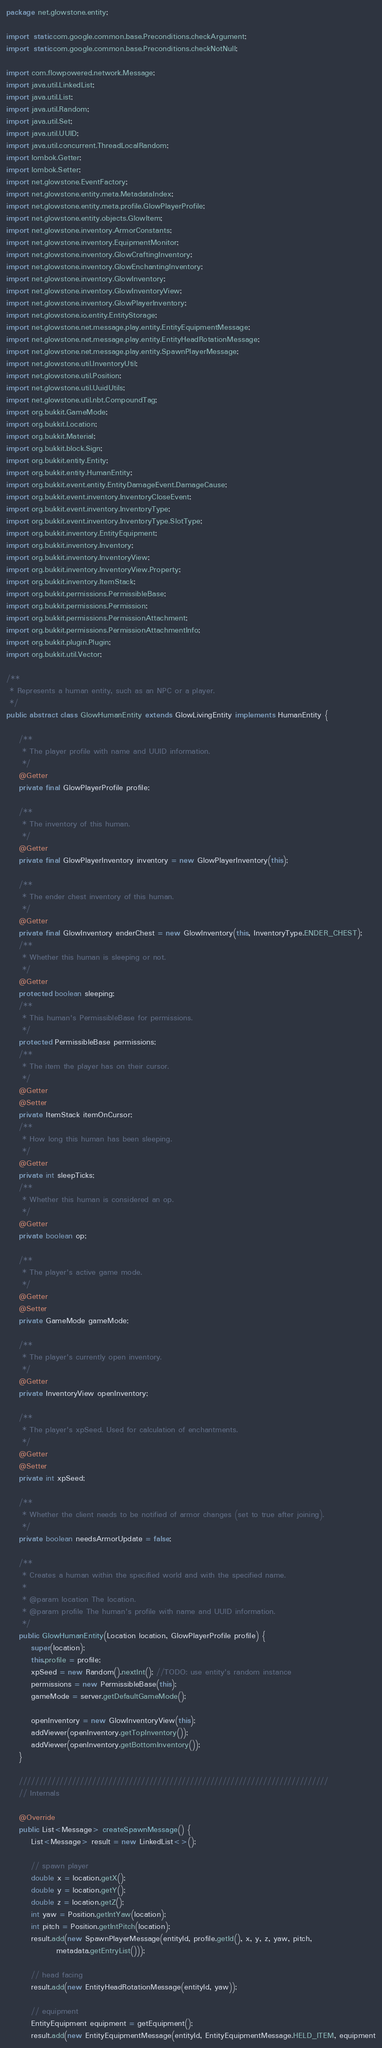Convert code to text. <code><loc_0><loc_0><loc_500><loc_500><_Java_>package net.glowstone.entity;

import static com.google.common.base.Preconditions.checkArgument;
import static com.google.common.base.Preconditions.checkNotNull;

import com.flowpowered.network.Message;
import java.util.LinkedList;
import java.util.List;
import java.util.Random;
import java.util.Set;
import java.util.UUID;
import java.util.concurrent.ThreadLocalRandom;
import lombok.Getter;
import lombok.Setter;
import net.glowstone.EventFactory;
import net.glowstone.entity.meta.MetadataIndex;
import net.glowstone.entity.meta.profile.GlowPlayerProfile;
import net.glowstone.entity.objects.GlowItem;
import net.glowstone.inventory.ArmorConstants;
import net.glowstone.inventory.EquipmentMonitor;
import net.glowstone.inventory.GlowCraftingInventory;
import net.glowstone.inventory.GlowEnchantingInventory;
import net.glowstone.inventory.GlowInventory;
import net.glowstone.inventory.GlowInventoryView;
import net.glowstone.inventory.GlowPlayerInventory;
import net.glowstone.io.entity.EntityStorage;
import net.glowstone.net.message.play.entity.EntityEquipmentMessage;
import net.glowstone.net.message.play.entity.EntityHeadRotationMessage;
import net.glowstone.net.message.play.entity.SpawnPlayerMessage;
import net.glowstone.util.InventoryUtil;
import net.glowstone.util.Position;
import net.glowstone.util.UuidUtils;
import net.glowstone.util.nbt.CompoundTag;
import org.bukkit.GameMode;
import org.bukkit.Location;
import org.bukkit.Material;
import org.bukkit.block.Sign;
import org.bukkit.entity.Entity;
import org.bukkit.entity.HumanEntity;
import org.bukkit.event.entity.EntityDamageEvent.DamageCause;
import org.bukkit.event.inventory.InventoryCloseEvent;
import org.bukkit.event.inventory.InventoryType;
import org.bukkit.event.inventory.InventoryType.SlotType;
import org.bukkit.inventory.EntityEquipment;
import org.bukkit.inventory.Inventory;
import org.bukkit.inventory.InventoryView;
import org.bukkit.inventory.InventoryView.Property;
import org.bukkit.inventory.ItemStack;
import org.bukkit.permissions.PermissibleBase;
import org.bukkit.permissions.Permission;
import org.bukkit.permissions.PermissionAttachment;
import org.bukkit.permissions.PermissionAttachmentInfo;
import org.bukkit.plugin.Plugin;
import org.bukkit.util.Vector;

/**
 * Represents a human entity, such as an NPC or a player.
 */
public abstract class GlowHumanEntity extends GlowLivingEntity implements HumanEntity {

    /**
     * The player profile with name and UUID information.
     */
    @Getter
    private final GlowPlayerProfile profile;

    /**
     * The inventory of this human.
     */
    @Getter
    private final GlowPlayerInventory inventory = new GlowPlayerInventory(this);

    /**
     * The ender chest inventory of this human.
     */
    @Getter
    private final GlowInventory enderChest = new GlowInventory(this, InventoryType.ENDER_CHEST);
    /**
     * Whether this human is sleeping or not.
     */
    @Getter
    protected boolean sleeping;
    /**
     * This human's PermissibleBase for permissions.
     */
    protected PermissibleBase permissions;
    /**
     * The item the player has on their cursor.
     */
    @Getter
    @Setter
    private ItemStack itemOnCursor;
    /**
     * How long this human has been sleeping.
     */
    @Getter
    private int sleepTicks;
    /**
     * Whether this human is considered an op.
     */
    @Getter
    private boolean op;

    /**
     * The player's active game mode.
     */
    @Getter
    @Setter
    private GameMode gameMode;

    /**
     * The player's currently open inventory.
     */
    @Getter
    private InventoryView openInventory;

    /**
     * The player's xpSeed. Used for calculation of enchantments.
     */
    @Getter
    @Setter
    private int xpSeed;

    /**
     * Whether the client needs to be notified of armor changes (set to true after joining).
     */
    private boolean needsArmorUpdate = false;

    /**
     * Creates a human within the specified world and with the specified name.
     *
     * @param location The location.
     * @param profile The human's profile with name and UUID information.
     */
    public GlowHumanEntity(Location location, GlowPlayerProfile profile) {
        super(location);
        this.profile = profile;
        xpSeed = new Random().nextInt(); //TODO: use entity's random instance
        permissions = new PermissibleBase(this);
        gameMode = server.getDefaultGameMode();

        openInventory = new GlowInventoryView(this);
        addViewer(openInventory.getTopInventory());
        addViewer(openInventory.getBottomInventory());
    }

    ////////////////////////////////////////////////////////////////////////////
    // Internals

    @Override
    public List<Message> createSpawnMessage() {
        List<Message> result = new LinkedList<>();

        // spawn player
        double x = location.getX();
        double y = location.getY();
        double z = location.getZ();
        int yaw = Position.getIntYaw(location);
        int pitch = Position.getIntPitch(location);
        result.add(new SpawnPlayerMessage(entityId, profile.getId(), x, y, z, yaw, pitch,
                metadata.getEntryList()));

        // head facing
        result.add(new EntityHeadRotationMessage(entityId, yaw));

        // equipment
        EntityEquipment equipment = getEquipment();
        result.add(new EntityEquipmentMessage(entityId, EntityEquipmentMessage.HELD_ITEM, equipment</code> 